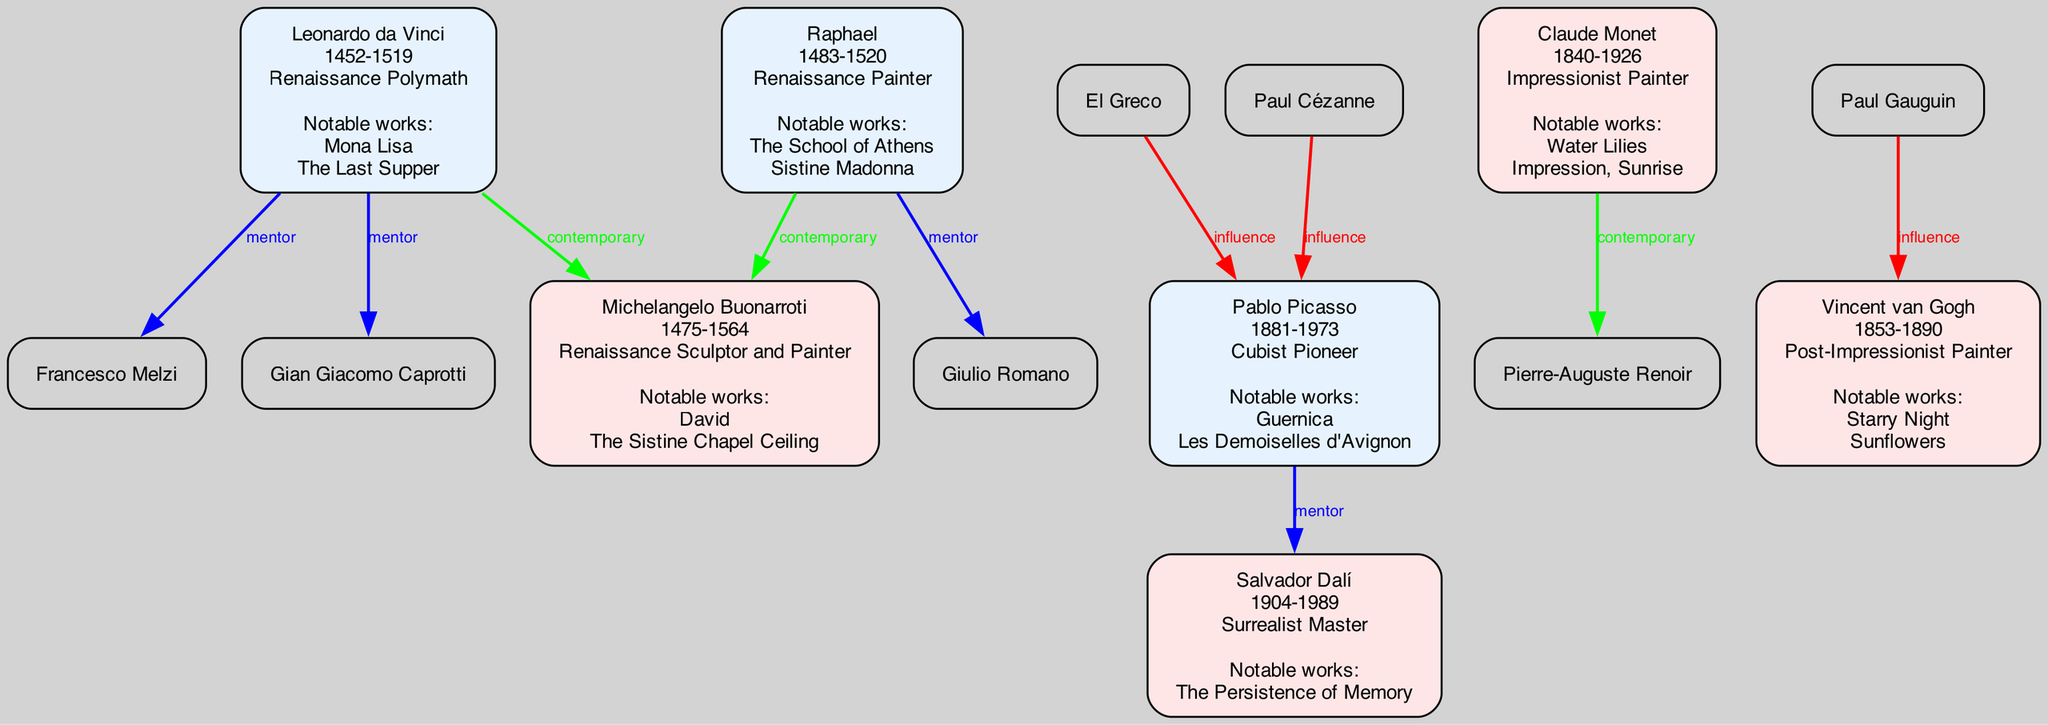What is the role of Leonardo da Vinci? The diagram indicates that Leonardo da Vinci is labeled as a "Renaissance Polymath." This information can be found within the box that represents him in the diagram.
Answer: Renaissance Polymath Who was a protege of Raphael? Looking at Raphael's box, we can see that Giulio Romano is listed as one of his proteges. This relationship is depicted in the diagram with a directed line indicating mentorship.
Answer: Giulio Romano How many contemporaries does Pablo Picasso have? Upon examining the diagram, Pablo Picasso's box shows that he has one contemporary, Georges Braque. Thus, by counting the mentioned contemporaries, we find that there is one.
Answer: 1 What notable work is associated with Vincent van Gogh? Vincent van Gogh's node contains the titles "Starry Night" and "Sunflowers" as his notable works. This can be directly seen within his box in the diagram.
Answer: Starry Night Which artist influenced Salvador Dalí? The diagram shows connections indicating influences, specifically, it states that Pablo Picasso and Sigmund Freud influenced Salvador Dalí. Therefore, referring to the relevant section under Dalí's box assists in identifying this.
Answer: Pablo Picasso Which type of connection exists between Leonardo da Vinci and Michelangelo Buonarroti? The diagram clearly shows the relationship between Leonardo da Vinci and Michelangelo Buonarroti as a "contemporary" connection, illustrated with a green line between their nodes.
Answer: Contemporary Who is the contemporary of Claude Monet? By analyzing Claude Monet's box, we find Pierre-Auguste Renoir mentioned as his contemporary. The diagram visually indicates this connection through a line on the same horizontal level as Monet.
Answer: Pierre-Auguste Renoir Which color represents mentor connections in the diagram? The diagram uses different colors to characterize the types of connections; mentor connections are indicated with a blue line. This coding helps to identify the relationship types at a glance.
Answer: Blue What notable work connects Raphael to Michelangelo Buonarroti? Raphael's box does not list any specific notable work connecting him to Michelangelo Buonarroti, but it indicates that they share the "contemporary" relationship type. Thus, there’s no direct work linking them in this diagram.
Answer: None 